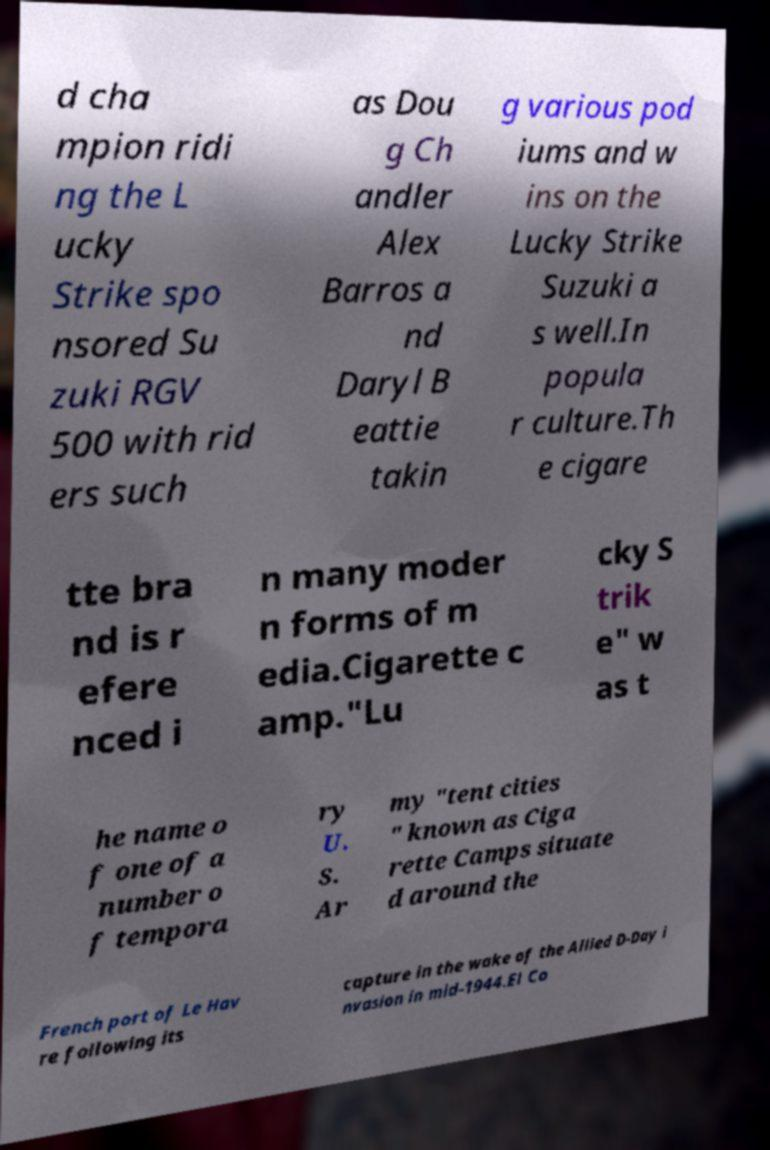I need the written content from this picture converted into text. Can you do that? d cha mpion ridi ng the L ucky Strike spo nsored Su zuki RGV 500 with rid ers such as Dou g Ch andler Alex Barros a nd Daryl B eattie takin g various pod iums and w ins on the Lucky Strike Suzuki a s well.In popula r culture.Th e cigare tte bra nd is r efere nced i n many moder n forms of m edia.Cigarette c amp."Lu cky S trik e" w as t he name o f one of a number o f tempora ry U. S. Ar my "tent cities " known as Ciga rette Camps situate d around the French port of Le Hav re following its capture in the wake of the Allied D-Day i nvasion in mid-1944.El Co 